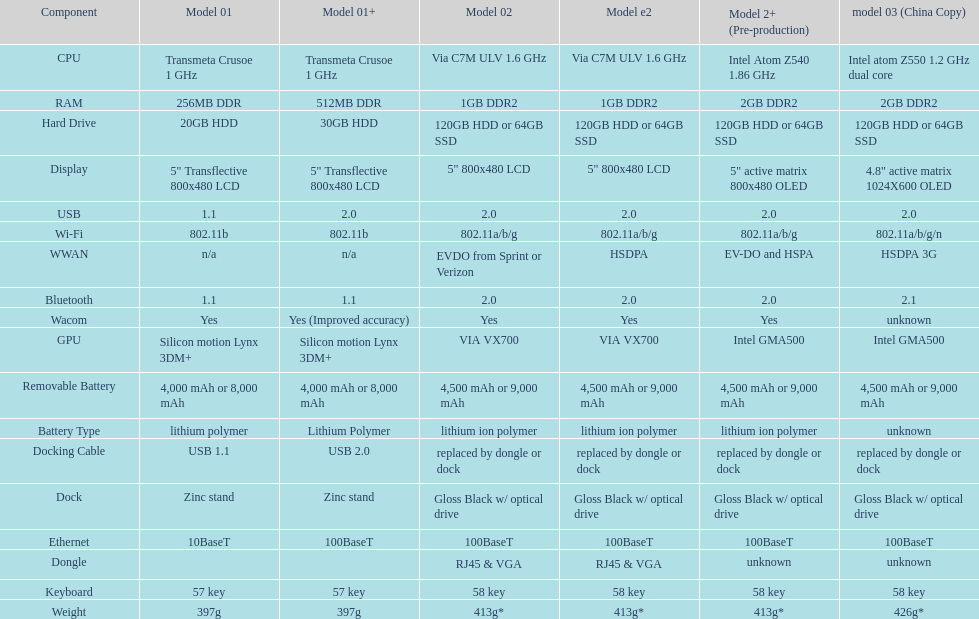For how many models is a usb docking cable used? 2. 